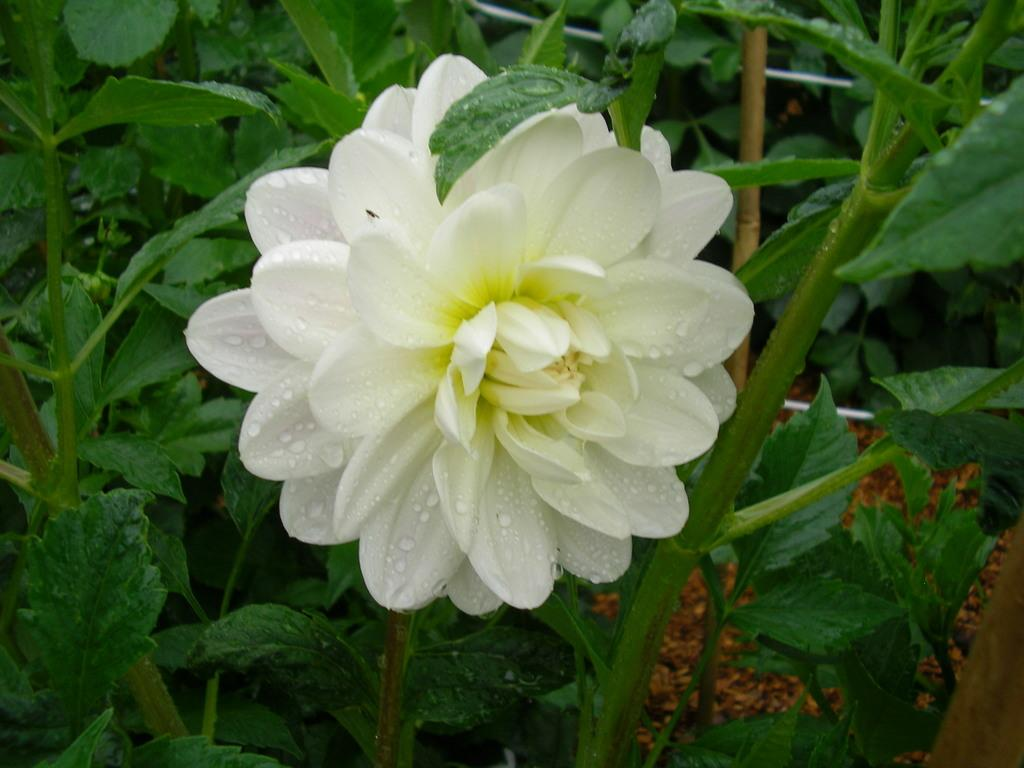What type of flower is on the plant in the image? There is a plant with a white flower in the image. What can be seen in the background of the image? There are plants with green leaves in the background of the image. Where are the plants with green leaves located? The plants with green leaves are on the ground. What type of reward or punishment is associated with the white flower in the image? There is no reward or punishment associated with the white flower in the image; it is simply a flower on a plant. 